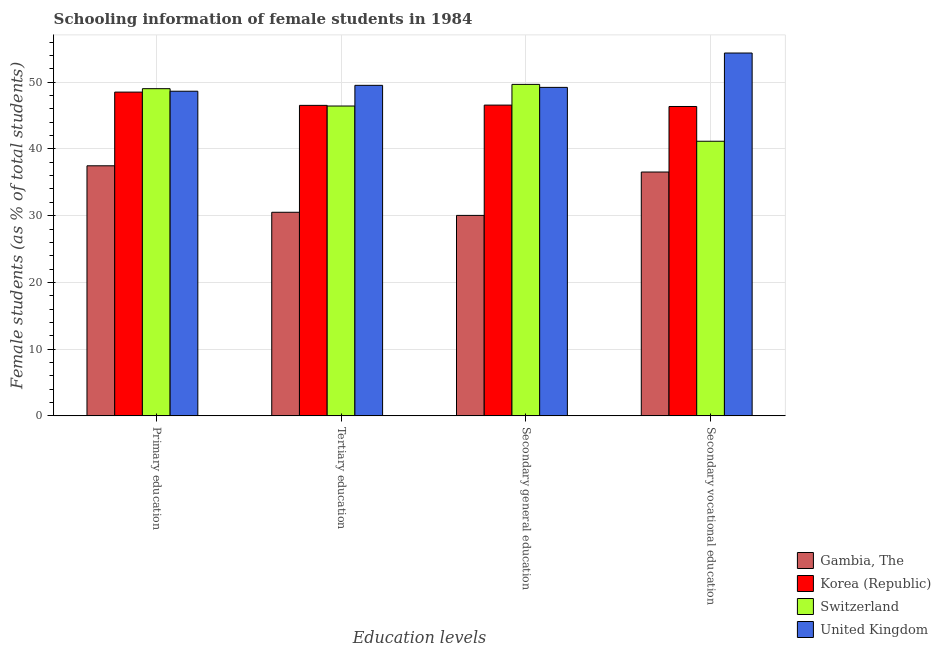Are the number of bars per tick equal to the number of legend labels?
Keep it short and to the point. Yes. Are the number of bars on each tick of the X-axis equal?
Your response must be concise. Yes. How many bars are there on the 2nd tick from the right?
Your response must be concise. 4. What is the label of the 3rd group of bars from the left?
Your response must be concise. Secondary general education. What is the percentage of female students in primary education in Gambia, The?
Your response must be concise. 37.47. Across all countries, what is the maximum percentage of female students in secondary vocational education?
Provide a short and direct response. 54.37. Across all countries, what is the minimum percentage of female students in tertiary education?
Offer a very short reply. 30.51. In which country was the percentage of female students in tertiary education maximum?
Your answer should be compact. United Kingdom. In which country was the percentage of female students in secondary education minimum?
Ensure brevity in your answer.  Gambia, The. What is the total percentage of female students in secondary education in the graph?
Your response must be concise. 175.49. What is the difference between the percentage of female students in tertiary education in Switzerland and that in United Kingdom?
Give a very brief answer. -3.1. What is the difference between the percentage of female students in tertiary education in Korea (Republic) and the percentage of female students in primary education in Gambia, The?
Provide a short and direct response. 9.06. What is the average percentage of female students in tertiary education per country?
Offer a terse response. 43.25. What is the difference between the percentage of female students in secondary vocational education and percentage of female students in tertiary education in Switzerland?
Keep it short and to the point. -5.28. What is the ratio of the percentage of female students in primary education in Switzerland to that in United Kingdom?
Offer a very short reply. 1.01. Is the percentage of female students in primary education in Gambia, The less than that in United Kingdom?
Your response must be concise. Yes. Is the difference between the percentage of female students in primary education in Gambia, The and Korea (Republic) greater than the difference between the percentage of female students in secondary vocational education in Gambia, The and Korea (Republic)?
Your answer should be very brief. No. What is the difference between the highest and the second highest percentage of female students in primary education?
Offer a very short reply. 0.38. What is the difference between the highest and the lowest percentage of female students in primary education?
Provide a short and direct response. 11.56. Is the sum of the percentage of female students in secondary education in Korea (Republic) and United Kingdom greater than the maximum percentage of female students in tertiary education across all countries?
Offer a very short reply. Yes. What does the 3rd bar from the left in Tertiary education represents?
Provide a short and direct response. Switzerland. Is it the case that in every country, the sum of the percentage of female students in primary education and percentage of female students in tertiary education is greater than the percentage of female students in secondary education?
Give a very brief answer. Yes. How many countries are there in the graph?
Offer a terse response. 4. Does the graph contain any zero values?
Provide a succinct answer. No. Where does the legend appear in the graph?
Give a very brief answer. Bottom right. What is the title of the graph?
Your answer should be very brief. Schooling information of female students in 1984. What is the label or title of the X-axis?
Your response must be concise. Education levels. What is the label or title of the Y-axis?
Keep it short and to the point. Female students (as % of total students). What is the Female students (as % of total students) of Gambia, The in Primary education?
Provide a succinct answer. 37.47. What is the Female students (as % of total students) in Korea (Republic) in Primary education?
Offer a terse response. 48.51. What is the Female students (as % of total students) of Switzerland in Primary education?
Your response must be concise. 49.03. What is the Female students (as % of total students) in United Kingdom in Primary education?
Your answer should be very brief. 48.64. What is the Female students (as % of total students) in Gambia, The in Tertiary education?
Make the answer very short. 30.51. What is the Female students (as % of total students) in Korea (Republic) in Tertiary education?
Provide a short and direct response. 46.53. What is the Female students (as % of total students) in Switzerland in Tertiary education?
Your answer should be very brief. 46.43. What is the Female students (as % of total students) in United Kingdom in Tertiary education?
Provide a short and direct response. 49.53. What is the Female students (as % of total students) in Gambia, The in Secondary general education?
Your answer should be compact. 30.04. What is the Female students (as % of total students) in Korea (Republic) in Secondary general education?
Keep it short and to the point. 46.57. What is the Female students (as % of total students) of Switzerland in Secondary general education?
Give a very brief answer. 49.67. What is the Female students (as % of total students) of United Kingdom in Secondary general education?
Offer a terse response. 49.22. What is the Female students (as % of total students) of Gambia, The in Secondary vocational education?
Make the answer very short. 36.54. What is the Female students (as % of total students) of Korea (Republic) in Secondary vocational education?
Keep it short and to the point. 46.36. What is the Female students (as % of total students) in Switzerland in Secondary vocational education?
Your answer should be compact. 41.15. What is the Female students (as % of total students) in United Kingdom in Secondary vocational education?
Ensure brevity in your answer.  54.37. Across all Education levels, what is the maximum Female students (as % of total students) of Gambia, The?
Give a very brief answer. 37.47. Across all Education levels, what is the maximum Female students (as % of total students) of Korea (Republic)?
Offer a very short reply. 48.51. Across all Education levels, what is the maximum Female students (as % of total students) of Switzerland?
Your answer should be very brief. 49.67. Across all Education levels, what is the maximum Female students (as % of total students) of United Kingdom?
Offer a very short reply. 54.37. Across all Education levels, what is the minimum Female students (as % of total students) of Gambia, The?
Your answer should be very brief. 30.04. Across all Education levels, what is the minimum Female students (as % of total students) of Korea (Republic)?
Give a very brief answer. 46.36. Across all Education levels, what is the minimum Female students (as % of total students) in Switzerland?
Offer a terse response. 41.15. Across all Education levels, what is the minimum Female students (as % of total students) in United Kingdom?
Your answer should be compact. 48.64. What is the total Female students (as % of total students) in Gambia, The in the graph?
Offer a very short reply. 134.55. What is the total Female students (as % of total students) of Korea (Republic) in the graph?
Keep it short and to the point. 187.96. What is the total Female students (as % of total students) of Switzerland in the graph?
Your answer should be compact. 186.27. What is the total Female students (as % of total students) in United Kingdom in the graph?
Offer a very short reply. 201.76. What is the difference between the Female students (as % of total students) of Gambia, The in Primary education and that in Tertiary education?
Provide a short and direct response. 6.96. What is the difference between the Female students (as % of total students) in Korea (Republic) in Primary education and that in Tertiary education?
Your answer should be very brief. 1.99. What is the difference between the Female students (as % of total students) in Switzerland in Primary education and that in Tertiary education?
Your answer should be compact. 2.6. What is the difference between the Female students (as % of total students) of United Kingdom in Primary education and that in Tertiary education?
Offer a terse response. -0.88. What is the difference between the Female students (as % of total students) in Gambia, The in Primary education and that in Secondary general education?
Your answer should be very brief. 7.43. What is the difference between the Female students (as % of total students) in Korea (Republic) in Primary education and that in Secondary general education?
Ensure brevity in your answer.  1.95. What is the difference between the Female students (as % of total students) of Switzerland in Primary education and that in Secondary general education?
Make the answer very short. -0.64. What is the difference between the Female students (as % of total students) of United Kingdom in Primary education and that in Secondary general education?
Your answer should be compact. -0.57. What is the difference between the Female students (as % of total students) in Gambia, The in Primary education and that in Secondary vocational education?
Offer a very short reply. 0.93. What is the difference between the Female students (as % of total students) in Korea (Republic) in Primary education and that in Secondary vocational education?
Your answer should be compact. 2.16. What is the difference between the Female students (as % of total students) of Switzerland in Primary education and that in Secondary vocational education?
Your response must be concise. 7.88. What is the difference between the Female students (as % of total students) of United Kingdom in Primary education and that in Secondary vocational education?
Keep it short and to the point. -5.73. What is the difference between the Female students (as % of total students) in Gambia, The in Tertiary education and that in Secondary general education?
Keep it short and to the point. 0.47. What is the difference between the Female students (as % of total students) of Korea (Republic) in Tertiary education and that in Secondary general education?
Make the answer very short. -0.04. What is the difference between the Female students (as % of total students) of Switzerland in Tertiary education and that in Secondary general education?
Your answer should be compact. -3.24. What is the difference between the Female students (as % of total students) of United Kingdom in Tertiary education and that in Secondary general education?
Offer a very short reply. 0.31. What is the difference between the Female students (as % of total students) in Gambia, The in Tertiary education and that in Secondary vocational education?
Keep it short and to the point. -6.03. What is the difference between the Female students (as % of total students) in Korea (Republic) in Tertiary education and that in Secondary vocational education?
Your response must be concise. 0.17. What is the difference between the Female students (as % of total students) of Switzerland in Tertiary education and that in Secondary vocational education?
Your response must be concise. 5.28. What is the difference between the Female students (as % of total students) of United Kingdom in Tertiary education and that in Secondary vocational education?
Offer a terse response. -4.84. What is the difference between the Female students (as % of total students) of Gambia, The in Secondary general education and that in Secondary vocational education?
Your answer should be compact. -6.5. What is the difference between the Female students (as % of total students) of Korea (Republic) in Secondary general education and that in Secondary vocational education?
Offer a very short reply. 0.21. What is the difference between the Female students (as % of total students) of Switzerland in Secondary general education and that in Secondary vocational education?
Offer a very short reply. 8.52. What is the difference between the Female students (as % of total students) in United Kingdom in Secondary general education and that in Secondary vocational education?
Offer a terse response. -5.15. What is the difference between the Female students (as % of total students) in Gambia, The in Primary education and the Female students (as % of total students) in Korea (Republic) in Tertiary education?
Ensure brevity in your answer.  -9.06. What is the difference between the Female students (as % of total students) in Gambia, The in Primary education and the Female students (as % of total students) in Switzerland in Tertiary education?
Offer a very short reply. -8.96. What is the difference between the Female students (as % of total students) in Gambia, The in Primary education and the Female students (as % of total students) in United Kingdom in Tertiary education?
Offer a terse response. -12.06. What is the difference between the Female students (as % of total students) of Korea (Republic) in Primary education and the Female students (as % of total students) of Switzerland in Tertiary education?
Make the answer very short. 2.09. What is the difference between the Female students (as % of total students) of Korea (Republic) in Primary education and the Female students (as % of total students) of United Kingdom in Tertiary education?
Your answer should be compact. -1.01. What is the difference between the Female students (as % of total students) in Switzerland in Primary education and the Female students (as % of total students) in United Kingdom in Tertiary education?
Your response must be concise. -0.5. What is the difference between the Female students (as % of total students) in Gambia, The in Primary education and the Female students (as % of total students) in Korea (Republic) in Secondary general education?
Keep it short and to the point. -9.1. What is the difference between the Female students (as % of total students) in Gambia, The in Primary education and the Female students (as % of total students) in Switzerland in Secondary general education?
Make the answer very short. -12.2. What is the difference between the Female students (as % of total students) of Gambia, The in Primary education and the Female students (as % of total students) of United Kingdom in Secondary general education?
Keep it short and to the point. -11.75. What is the difference between the Female students (as % of total students) in Korea (Republic) in Primary education and the Female students (as % of total students) in Switzerland in Secondary general education?
Offer a very short reply. -1.16. What is the difference between the Female students (as % of total students) in Korea (Republic) in Primary education and the Female students (as % of total students) in United Kingdom in Secondary general education?
Your response must be concise. -0.71. What is the difference between the Female students (as % of total students) of Switzerland in Primary education and the Female students (as % of total students) of United Kingdom in Secondary general education?
Offer a terse response. -0.19. What is the difference between the Female students (as % of total students) in Gambia, The in Primary education and the Female students (as % of total students) in Korea (Republic) in Secondary vocational education?
Give a very brief answer. -8.89. What is the difference between the Female students (as % of total students) of Gambia, The in Primary education and the Female students (as % of total students) of Switzerland in Secondary vocational education?
Provide a succinct answer. -3.68. What is the difference between the Female students (as % of total students) in Gambia, The in Primary education and the Female students (as % of total students) in United Kingdom in Secondary vocational education?
Provide a succinct answer. -16.9. What is the difference between the Female students (as % of total students) in Korea (Republic) in Primary education and the Female students (as % of total students) in Switzerland in Secondary vocational education?
Offer a terse response. 7.36. What is the difference between the Female students (as % of total students) in Korea (Republic) in Primary education and the Female students (as % of total students) in United Kingdom in Secondary vocational education?
Provide a short and direct response. -5.86. What is the difference between the Female students (as % of total students) in Switzerland in Primary education and the Female students (as % of total students) in United Kingdom in Secondary vocational education?
Make the answer very short. -5.34. What is the difference between the Female students (as % of total students) in Gambia, The in Tertiary education and the Female students (as % of total students) in Korea (Republic) in Secondary general education?
Your response must be concise. -16.06. What is the difference between the Female students (as % of total students) in Gambia, The in Tertiary education and the Female students (as % of total students) in Switzerland in Secondary general education?
Your answer should be very brief. -19.16. What is the difference between the Female students (as % of total students) in Gambia, The in Tertiary education and the Female students (as % of total students) in United Kingdom in Secondary general education?
Offer a very short reply. -18.71. What is the difference between the Female students (as % of total students) of Korea (Republic) in Tertiary education and the Female students (as % of total students) of Switzerland in Secondary general education?
Provide a succinct answer. -3.14. What is the difference between the Female students (as % of total students) in Korea (Republic) in Tertiary education and the Female students (as % of total students) in United Kingdom in Secondary general education?
Make the answer very short. -2.69. What is the difference between the Female students (as % of total students) of Switzerland in Tertiary education and the Female students (as % of total students) of United Kingdom in Secondary general education?
Provide a succinct answer. -2.79. What is the difference between the Female students (as % of total students) in Gambia, The in Tertiary education and the Female students (as % of total students) in Korea (Republic) in Secondary vocational education?
Ensure brevity in your answer.  -15.85. What is the difference between the Female students (as % of total students) of Gambia, The in Tertiary education and the Female students (as % of total students) of Switzerland in Secondary vocational education?
Your response must be concise. -10.64. What is the difference between the Female students (as % of total students) of Gambia, The in Tertiary education and the Female students (as % of total students) of United Kingdom in Secondary vocational education?
Ensure brevity in your answer.  -23.86. What is the difference between the Female students (as % of total students) in Korea (Republic) in Tertiary education and the Female students (as % of total students) in Switzerland in Secondary vocational education?
Offer a very short reply. 5.38. What is the difference between the Female students (as % of total students) in Korea (Republic) in Tertiary education and the Female students (as % of total students) in United Kingdom in Secondary vocational education?
Keep it short and to the point. -7.84. What is the difference between the Female students (as % of total students) in Switzerland in Tertiary education and the Female students (as % of total students) in United Kingdom in Secondary vocational education?
Your answer should be very brief. -7.94. What is the difference between the Female students (as % of total students) in Gambia, The in Secondary general education and the Female students (as % of total students) in Korea (Republic) in Secondary vocational education?
Make the answer very short. -16.32. What is the difference between the Female students (as % of total students) in Gambia, The in Secondary general education and the Female students (as % of total students) in Switzerland in Secondary vocational education?
Provide a succinct answer. -11.11. What is the difference between the Female students (as % of total students) of Gambia, The in Secondary general education and the Female students (as % of total students) of United Kingdom in Secondary vocational education?
Provide a short and direct response. -24.33. What is the difference between the Female students (as % of total students) of Korea (Republic) in Secondary general education and the Female students (as % of total students) of Switzerland in Secondary vocational education?
Your response must be concise. 5.42. What is the difference between the Female students (as % of total students) of Korea (Republic) in Secondary general education and the Female students (as % of total students) of United Kingdom in Secondary vocational education?
Your answer should be compact. -7.8. What is the difference between the Female students (as % of total students) in Switzerland in Secondary general education and the Female students (as % of total students) in United Kingdom in Secondary vocational education?
Ensure brevity in your answer.  -4.7. What is the average Female students (as % of total students) in Gambia, The per Education levels?
Your response must be concise. 33.64. What is the average Female students (as % of total students) of Korea (Republic) per Education levels?
Offer a very short reply. 46.99. What is the average Female students (as % of total students) of Switzerland per Education levels?
Make the answer very short. 46.57. What is the average Female students (as % of total students) in United Kingdom per Education levels?
Make the answer very short. 50.44. What is the difference between the Female students (as % of total students) of Gambia, The and Female students (as % of total students) of Korea (Republic) in Primary education?
Your answer should be very brief. -11.04. What is the difference between the Female students (as % of total students) of Gambia, The and Female students (as % of total students) of Switzerland in Primary education?
Offer a terse response. -11.56. What is the difference between the Female students (as % of total students) in Gambia, The and Female students (as % of total students) in United Kingdom in Primary education?
Offer a very short reply. -11.17. What is the difference between the Female students (as % of total students) in Korea (Republic) and Female students (as % of total students) in Switzerland in Primary education?
Your answer should be very brief. -0.51. What is the difference between the Female students (as % of total students) of Korea (Republic) and Female students (as % of total students) of United Kingdom in Primary education?
Provide a short and direct response. -0.13. What is the difference between the Female students (as % of total students) in Switzerland and Female students (as % of total students) in United Kingdom in Primary education?
Offer a very short reply. 0.38. What is the difference between the Female students (as % of total students) in Gambia, The and Female students (as % of total students) in Korea (Republic) in Tertiary education?
Your answer should be compact. -16.02. What is the difference between the Female students (as % of total students) in Gambia, The and Female students (as % of total students) in Switzerland in Tertiary education?
Offer a very short reply. -15.92. What is the difference between the Female students (as % of total students) of Gambia, The and Female students (as % of total students) of United Kingdom in Tertiary education?
Ensure brevity in your answer.  -19.02. What is the difference between the Female students (as % of total students) in Korea (Republic) and Female students (as % of total students) in Switzerland in Tertiary education?
Offer a very short reply. 0.1. What is the difference between the Female students (as % of total students) in Korea (Republic) and Female students (as % of total students) in United Kingdom in Tertiary education?
Make the answer very short. -3. What is the difference between the Female students (as % of total students) of Switzerland and Female students (as % of total students) of United Kingdom in Tertiary education?
Keep it short and to the point. -3.1. What is the difference between the Female students (as % of total students) in Gambia, The and Female students (as % of total students) in Korea (Republic) in Secondary general education?
Your answer should be compact. -16.53. What is the difference between the Female students (as % of total students) of Gambia, The and Female students (as % of total students) of Switzerland in Secondary general education?
Make the answer very short. -19.63. What is the difference between the Female students (as % of total students) of Gambia, The and Female students (as % of total students) of United Kingdom in Secondary general education?
Give a very brief answer. -19.18. What is the difference between the Female students (as % of total students) of Korea (Republic) and Female students (as % of total students) of Switzerland in Secondary general education?
Give a very brief answer. -3.1. What is the difference between the Female students (as % of total students) in Korea (Republic) and Female students (as % of total students) in United Kingdom in Secondary general education?
Offer a terse response. -2.65. What is the difference between the Female students (as % of total students) in Switzerland and Female students (as % of total students) in United Kingdom in Secondary general education?
Offer a very short reply. 0.45. What is the difference between the Female students (as % of total students) in Gambia, The and Female students (as % of total students) in Korea (Republic) in Secondary vocational education?
Give a very brief answer. -9.82. What is the difference between the Female students (as % of total students) in Gambia, The and Female students (as % of total students) in Switzerland in Secondary vocational education?
Your response must be concise. -4.61. What is the difference between the Female students (as % of total students) of Gambia, The and Female students (as % of total students) of United Kingdom in Secondary vocational education?
Provide a short and direct response. -17.83. What is the difference between the Female students (as % of total students) of Korea (Republic) and Female students (as % of total students) of Switzerland in Secondary vocational education?
Offer a very short reply. 5.21. What is the difference between the Female students (as % of total students) of Korea (Republic) and Female students (as % of total students) of United Kingdom in Secondary vocational education?
Ensure brevity in your answer.  -8.01. What is the difference between the Female students (as % of total students) of Switzerland and Female students (as % of total students) of United Kingdom in Secondary vocational education?
Make the answer very short. -13.22. What is the ratio of the Female students (as % of total students) of Gambia, The in Primary education to that in Tertiary education?
Your response must be concise. 1.23. What is the ratio of the Female students (as % of total students) of Korea (Republic) in Primary education to that in Tertiary education?
Your answer should be very brief. 1.04. What is the ratio of the Female students (as % of total students) of Switzerland in Primary education to that in Tertiary education?
Offer a very short reply. 1.06. What is the ratio of the Female students (as % of total students) in United Kingdom in Primary education to that in Tertiary education?
Offer a terse response. 0.98. What is the ratio of the Female students (as % of total students) in Gambia, The in Primary education to that in Secondary general education?
Keep it short and to the point. 1.25. What is the ratio of the Female students (as % of total students) of Korea (Republic) in Primary education to that in Secondary general education?
Give a very brief answer. 1.04. What is the ratio of the Female students (as % of total students) in United Kingdom in Primary education to that in Secondary general education?
Ensure brevity in your answer.  0.99. What is the ratio of the Female students (as % of total students) in Gambia, The in Primary education to that in Secondary vocational education?
Make the answer very short. 1.03. What is the ratio of the Female students (as % of total students) of Korea (Republic) in Primary education to that in Secondary vocational education?
Provide a succinct answer. 1.05. What is the ratio of the Female students (as % of total students) of Switzerland in Primary education to that in Secondary vocational education?
Provide a short and direct response. 1.19. What is the ratio of the Female students (as % of total students) of United Kingdom in Primary education to that in Secondary vocational education?
Make the answer very short. 0.89. What is the ratio of the Female students (as % of total students) of Gambia, The in Tertiary education to that in Secondary general education?
Give a very brief answer. 1.02. What is the ratio of the Female students (as % of total students) in Korea (Republic) in Tertiary education to that in Secondary general education?
Provide a succinct answer. 1. What is the ratio of the Female students (as % of total students) of Switzerland in Tertiary education to that in Secondary general education?
Provide a short and direct response. 0.93. What is the ratio of the Female students (as % of total students) of United Kingdom in Tertiary education to that in Secondary general education?
Your response must be concise. 1.01. What is the ratio of the Female students (as % of total students) in Gambia, The in Tertiary education to that in Secondary vocational education?
Give a very brief answer. 0.83. What is the ratio of the Female students (as % of total students) in Korea (Republic) in Tertiary education to that in Secondary vocational education?
Make the answer very short. 1. What is the ratio of the Female students (as % of total students) in Switzerland in Tertiary education to that in Secondary vocational education?
Offer a very short reply. 1.13. What is the ratio of the Female students (as % of total students) of United Kingdom in Tertiary education to that in Secondary vocational education?
Offer a very short reply. 0.91. What is the ratio of the Female students (as % of total students) of Gambia, The in Secondary general education to that in Secondary vocational education?
Give a very brief answer. 0.82. What is the ratio of the Female students (as % of total students) of Korea (Republic) in Secondary general education to that in Secondary vocational education?
Your answer should be very brief. 1. What is the ratio of the Female students (as % of total students) of Switzerland in Secondary general education to that in Secondary vocational education?
Provide a succinct answer. 1.21. What is the ratio of the Female students (as % of total students) of United Kingdom in Secondary general education to that in Secondary vocational education?
Ensure brevity in your answer.  0.91. What is the difference between the highest and the second highest Female students (as % of total students) of Gambia, The?
Keep it short and to the point. 0.93. What is the difference between the highest and the second highest Female students (as % of total students) in Korea (Republic)?
Make the answer very short. 1.95. What is the difference between the highest and the second highest Female students (as % of total students) of Switzerland?
Ensure brevity in your answer.  0.64. What is the difference between the highest and the second highest Female students (as % of total students) in United Kingdom?
Provide a succinct answer. 4.84. What is the difference between the highest and the lowest Female students (as % of total students) of Gambia, The?
Offer a very short reply. 7.43. What is the difference between the highest and the lowest Female students (as % of total students) of Korea (Republic)?
Your answer should be very brief. 2.16. What is the difference between the highest and the lowest Female students (as % of total students) in Switzerland?
Provide a succinct answer. 8.52. What is the difference between the highest and the lowest Female students (as % of total students) of United Kingdom?
Offer a terse response. 5.73. 